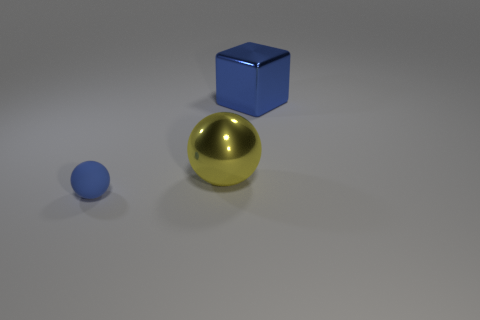The ball that is behind the sphere left of the ball that is to the right of the small matte thing is what color? The color of the ball positioned behind the sphere, which is to the left of the other ball next to the small matte object, appears to be blue. 